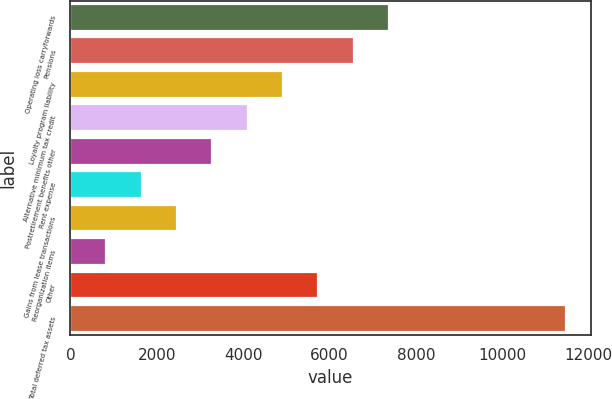Convert chart to OTSL. <chart><loc_0><loc_0><loc_500><loc_500><bar_chart><fcel>Operating loss carryforwards<fcel>Pensions<fcel>Loyalty program liability<fcel>Alternative minimum tax credit<fcel>Postretirement benefits other<fcel>Rent expense<fcel>Gains from lease transactions<fcel>Reorganization items<fcel>Other<fcel>Total deferred tax assets<nl><fcel>7382.3<fcel>6563.6<fcel>4926.2<fcel>4107.5<fcel>3288.8<fcel>1651.4<fcel>2470.1<fcel>832.7<fcel>5744.9<fcel>11475.8<nl></chart> 